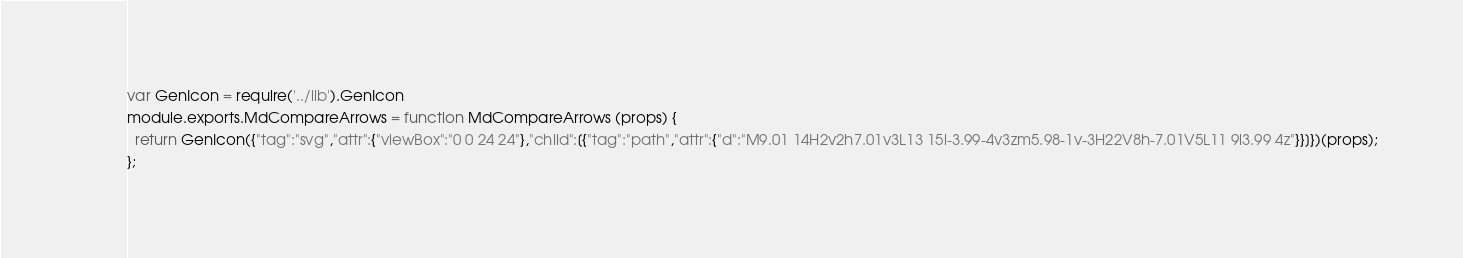<code> <loc_0><loc_0><loc_500><loc_500><_JavaScript_>var GenIcon = require('../lib').GenIcon
module.exports.MdCompareArrows = function MdCompareArrows (props) {
  return GenIcon({"tag":"svg","attr":{"viewBox":"0 0 24 24"},"child":[{"tag":"path","attr":{"d":"M9.01 14H2v2h7.01v3L13 15l-3.99-4v3zm5.98-1v-3H22V8h-7.01V5L11 9l3.99 4z"}}]})(props);
};
</code> 